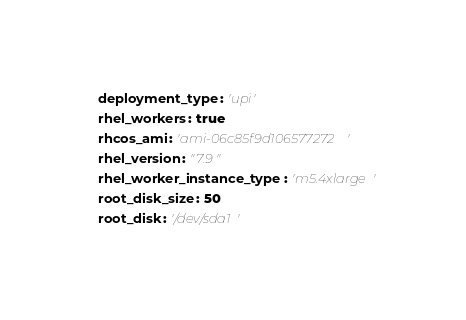Convert code to text. <code><loc_0><loc_0><loc_500><loc_500><_YAML_>  deployment_type: 'upi'
  rhel_workers: true
  rhcos_ami: 'ami-06c85f9d106577272'
  rhel_version: "7.9"
  rhel_worker_instance_type: 'm5.4xlarge'
  root_disk_size: 50
  root_disk: '/dev/sda1'
</code> 